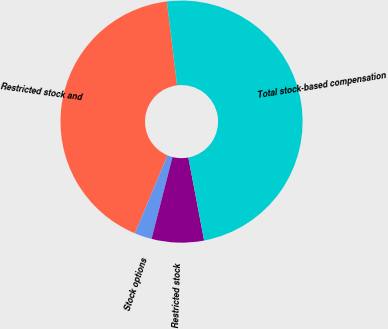Convert chart. <chart><loc_0><loc_0><loc_500><loc_500><pie_chart><fcel>Restricted stock and<fcel>Stock options<fcel>Restricted stock<fcel>Total stock-based compensation<nl><fcel>41.78%<fcel>2.31%<fcel>6.97%<fcel>48.94%<nl></chart> 